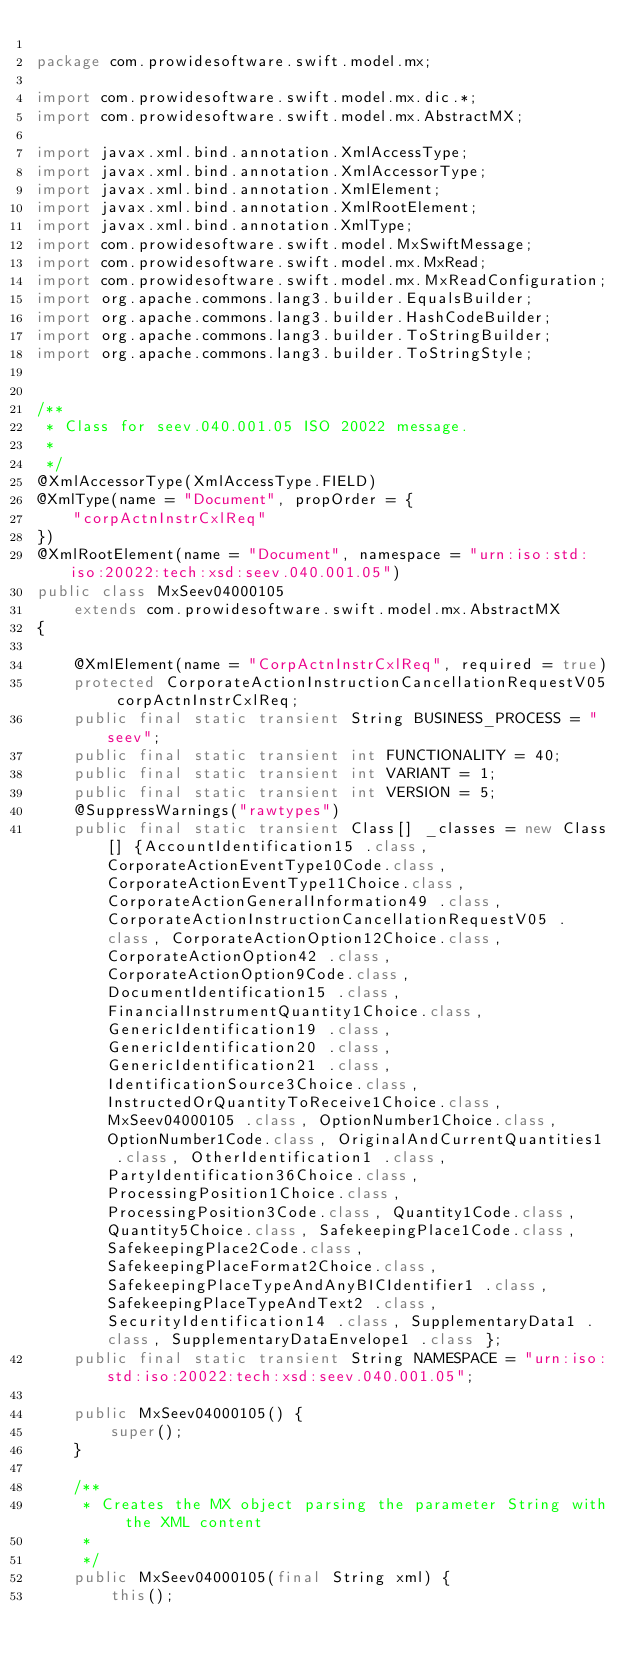Convert code to text. <code><loc_0><loc_0><loc_500><loc_500><_Java_>
package com.prowidesoftware.swift.model.mx;

import com.prowidesoftware.swift.model.mx.dic.*;
import com.prowidesoftware.swift.model.mx.AbstractMX;

import javax.xml.bind.annotation.XmlAccessType;
import javax.xml.bind.annotation.XmlAccessorType;
import javax.xml.bind.annotation.XmlElement;
import javax.xml.bind.annotation.XmlRootElement;
import javax.xml.bind.annotation.XmlType;
import com.prowidesoftware.swift.model.MxSwiftMessage;
import com.prowidesoftware.swift.model.mx.MxRead;
import com.prowidesoftware.swift.model.mx.MxReadConfiguration;
import org.apache.commons.lang3.builder.EqualsBuilder;
import org.apache.commons.lang3.builder.HashCodeBuilder;
import org.apache.commons.lang3.builder.ToStringBuilder;
import org.apache.commons.lang3.builder.ToStringStyle;


/**
 * Class for seev.040.001.05 ISO 20022 message.
 * 
 */
@XmlAccessorType(XmlAccessType.FIELD)
@XmlType(name = "Document", propOrder = {
    "corpActnInstrCxlReq"
})
@XmlRootElement(name = "Document", namespace = "urn:iso:std:iso:20022:tech:xsd:seev.040.001.05")
public class MxSeev04000105
    extends com.prowidesoftware.swift.model.mx.AbstractMX
{

    @XmlElement(name = "CorpActnInstrCxlReq", required = true)
    protected CorporateActionInstructionCancellationRequestV05 corpActnInstrCxlReq;
    public final static transient String BUSINESS_PROCESS = "seev";
    public final static transient int FUNCTIONALITY = 40;
    public final static transient int VARIANT = 1;
    public final static transient int VERSION = 5;
    @SuppressWarnings("rawtypes")
    public final static transient Class[] _classes = new Class[] {AccountIdentification15 .class, CorporateActionEventType10Code.class, CorporateActionEventType11Choice.class, CorporateActionGeneralInformation49 .class, CorporateActionInstructionCancellationRequestV05 .class, CorporateActionOption12Choice.class, CorporateActionOption42 .class, CorporateActionOption9Code.class, DocumentIdentification15 .class, FinancialInstrumentQuantity1Choice.class, GenericIdentification19 .class, GenericIdentification20 .class, GenericIdentification21 .class, IdentificationSource3Choice.class, InstructedOrQuantityToReceive1Choice.class, MxSeev04000105 .class, OptionNumber1Choice.class, OptionNumber1Code.class, OriginalAndCurrentQuantities1 .class, OtherIdentification1 .class, PartyIdentification36Choice.class, ProcessingPosition1Choice.class, ProcessingPosition3Code.class, Quantity1Code.class, Quantity5Choice.class, SafekeepingPlace1Code.class, SafekeepingPlace2Code.class, SafekeepingPlaceFormat2Choice.class, SafekeepingPlaceTypeAndAnyBICIdentifier1 .class, SafekeepingPlaceTypeAndText2 .class, SecurityIdentification14 .class, SupplementaryData1 .class, SupplementaryDataEnvelope1 .class };
    public final static transient String NAMESPACE = "urn:iso:std:iso:20022:tech:xsd:seev.040.001.05";

    public MxSeev04000105() {
        super();
    }

    /**
     * Creates the MX object parsing the parameter String with the XML content
     * 
     */
    public MxSeev04000105(final String xml) {
        this();</code> 